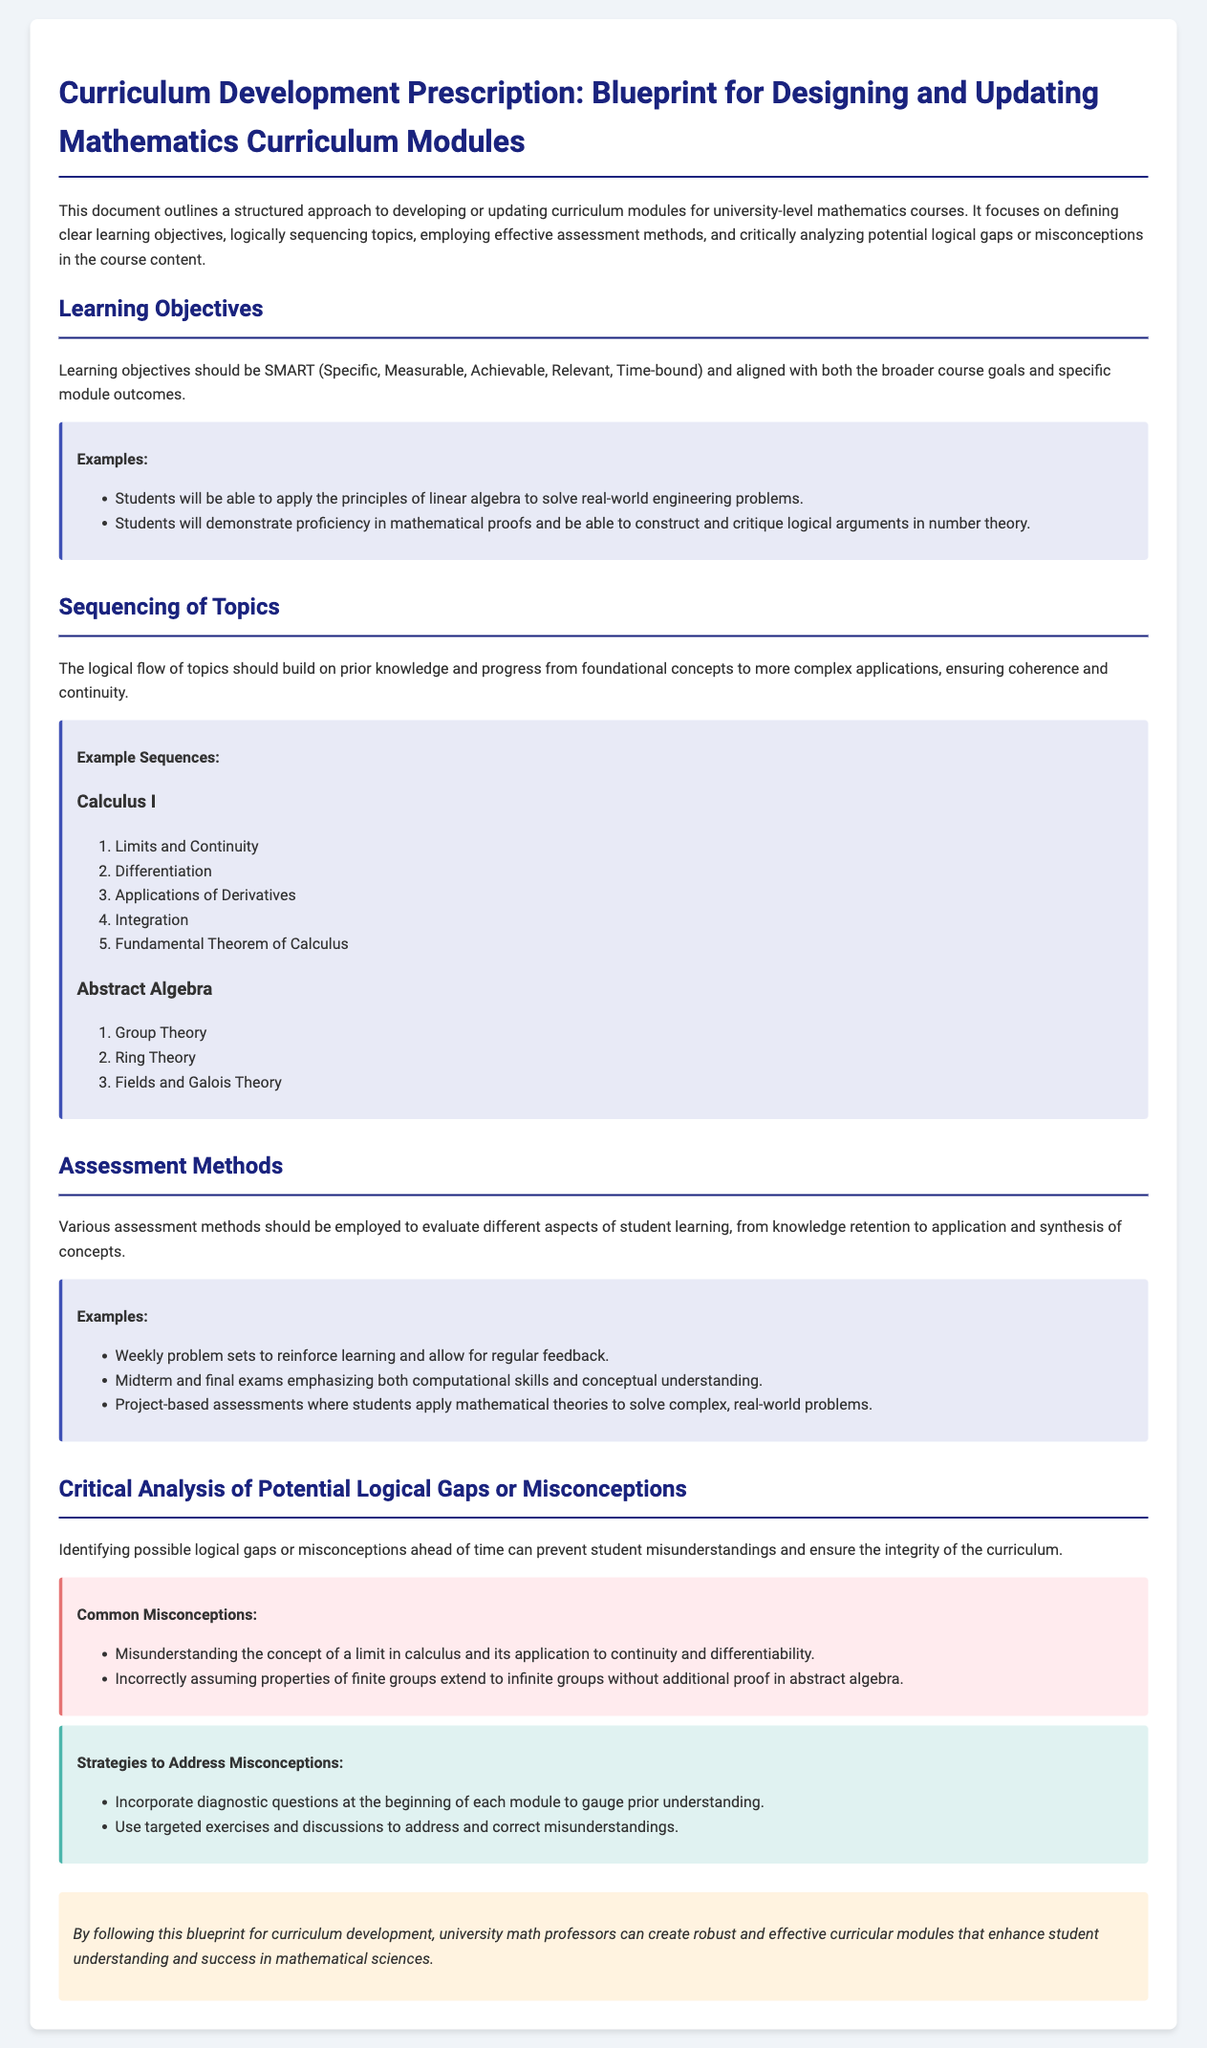What is the title of the document? The title is clearly stated at the beginning of the document, which is "Curriculum Development Prescription: Blueprint for Designing and Updating Mathematics Curriculum Modules."
Answer: Curriculum Development Prescription: Blueprint for Designing and Updating Mathematics Curriculum Modules What does SMART stand for in learning objectives? In the context of learning objectives, SMART stands for Specific, Measurable, Achievable, Relevant, Time-bound.
Answer: Specific, Measurable, Achievable, Relevant, Time-bound How many assessment methods are listed in the document? The document lists three distinct assessment methods, each aimed at evaluating different aspects of student learning.
Answer: Three What is the first topic in the Calculus I sequence? The sequenced topics in Calculus I start with the topic of "Limits and Continuity."
Answer: Limits and Continuity What is one common misconception listed in the document? One common misconception mentioned in the document is "Misunderstanding the concept of a limit in calculus and its application to continuity and differentiability."
Answer: Misunderstanding the concept of a limit What is the primary purpose of incorporating diagnostic questions? The primary purpose of incorporating diagnostic questions is to gauge prior understanding before starting each module, helping to identify any existing misconceptions.
Answer: Gauge prior understanding What is the main focus of the document? The document focuses on creating a blueprint for effectively developing or updating curriculum modules for university-level mathematics courses.
Answer: Blueprint for effectively developing or updating curriculum modules What color is used for the "Common Misconceptions" section? The "Common Misconceptions" section is highlighted using a background color of light red, specifically "#ffebee."
Answer: Light red What educational level is the curriculum intended for? The curriculum modules are specifically targeted at university-level mathematics courses.
Answer: University-level 